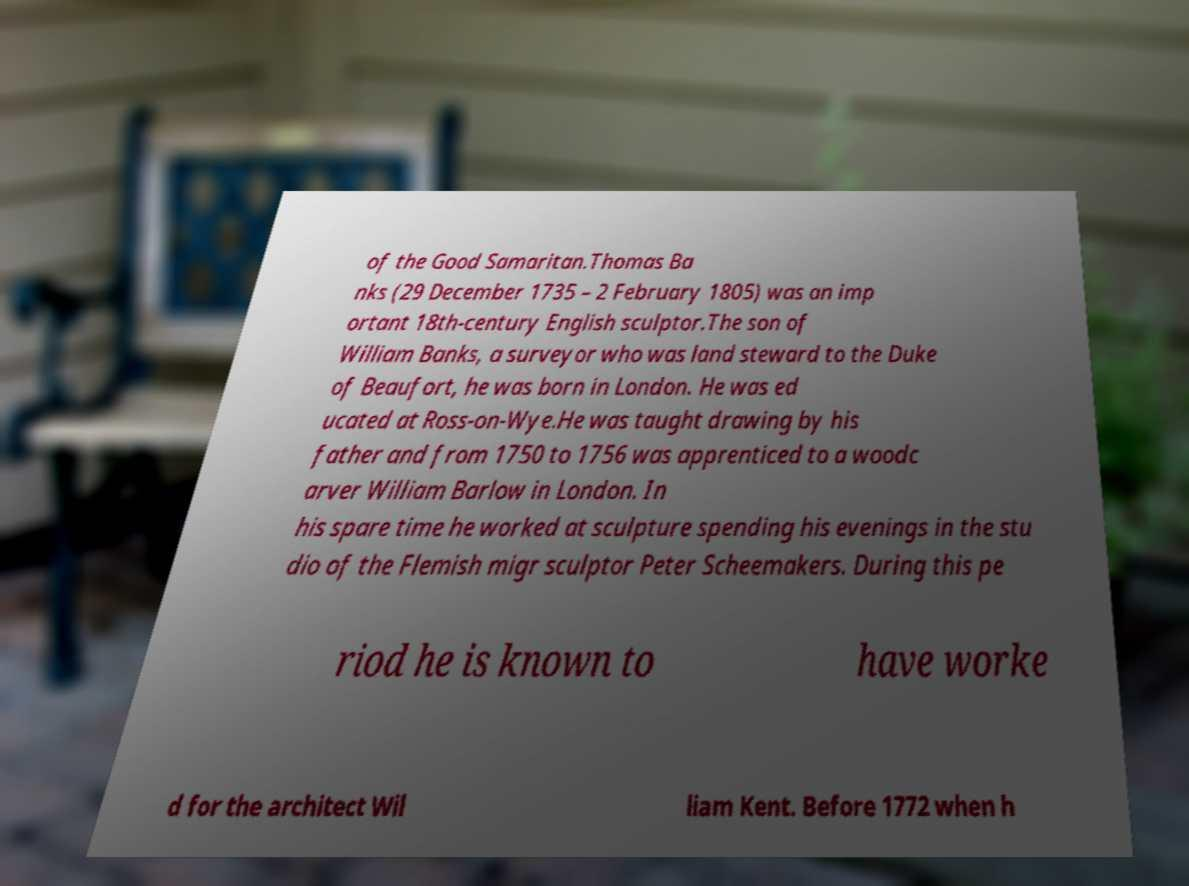I need the written content from this picture converted into text. Can you do that? of the Good Samaritan.Thomas Ba nks (29 December 1735 – 2 February 1805) was an imp ortant 18th-century English sculptor.The son of William Banks, a surveyor who was land steward to the Duke of Beaufort, he was born in London. He was ed ucated at Ross-on-Wye.He was taught drawing by his father and from 1750 to 1756 was apprenticed to a woodc arver William Barlow in London. In his spare time he worked at sculpture spending his evenings in the stu dio of the Flemish migr sculptor Peter Scheemakers. During this pe riod he is known to have worke d for the architect Wil liam Kent. Before 1772 when h 